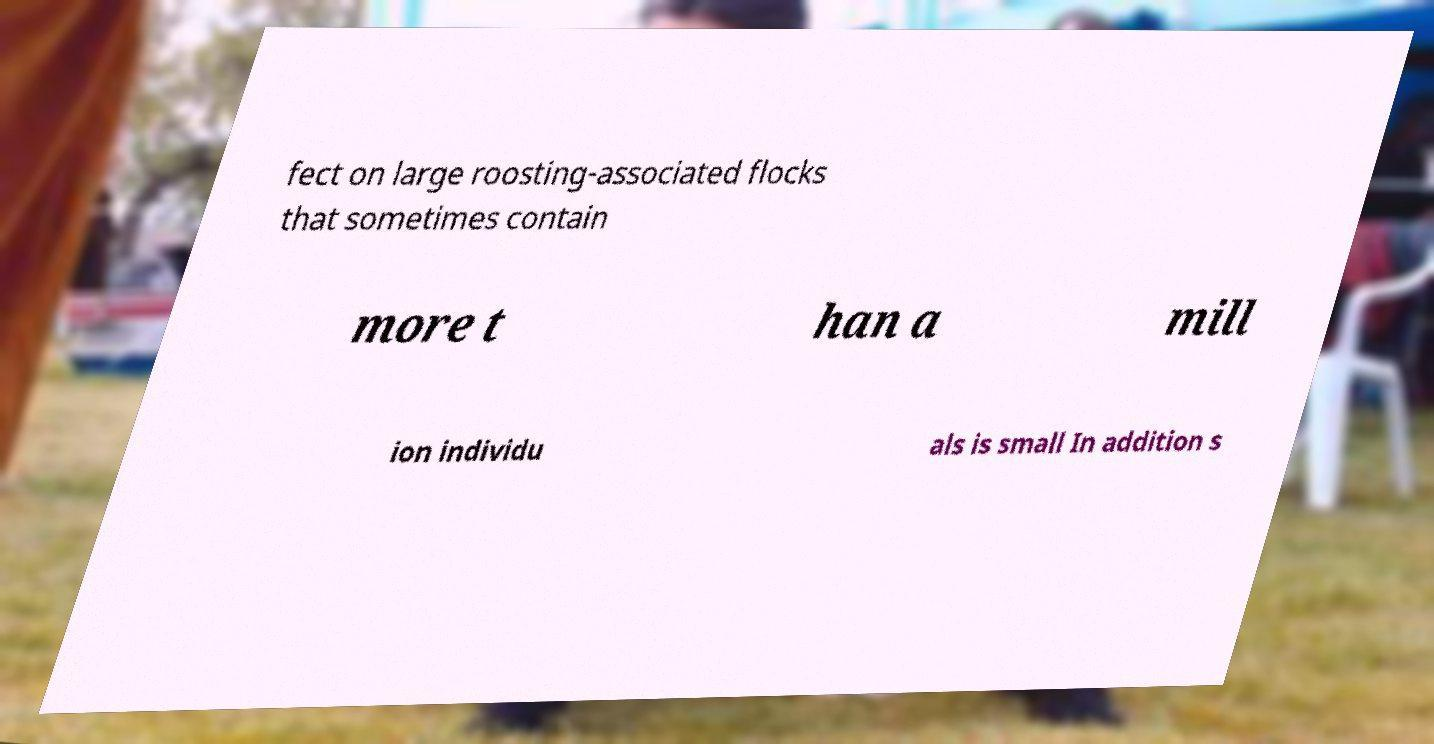There's text embedded in this image that I need extracted. Can you transcribe it verbatim? fect on large roosting-associated flocks that sometimes contain more t han a mill ion individu als is small In addition s 